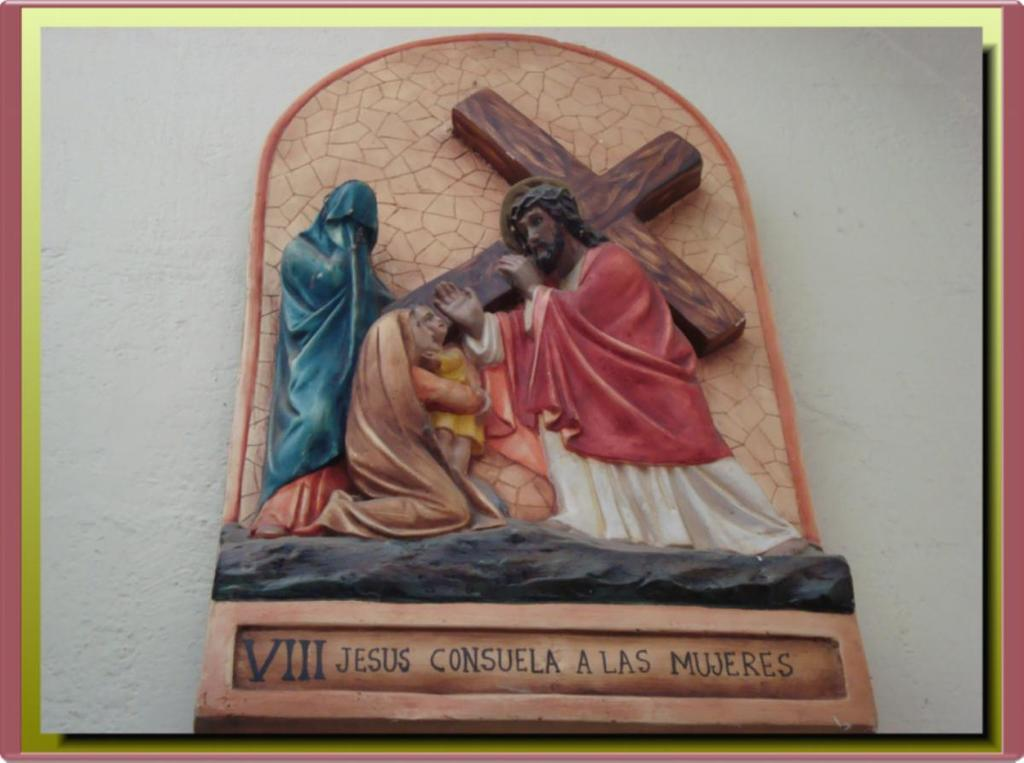<image>
Render a clear and concise summary of the photo. A crucifixion scene with the word Jesus at the bottom. 